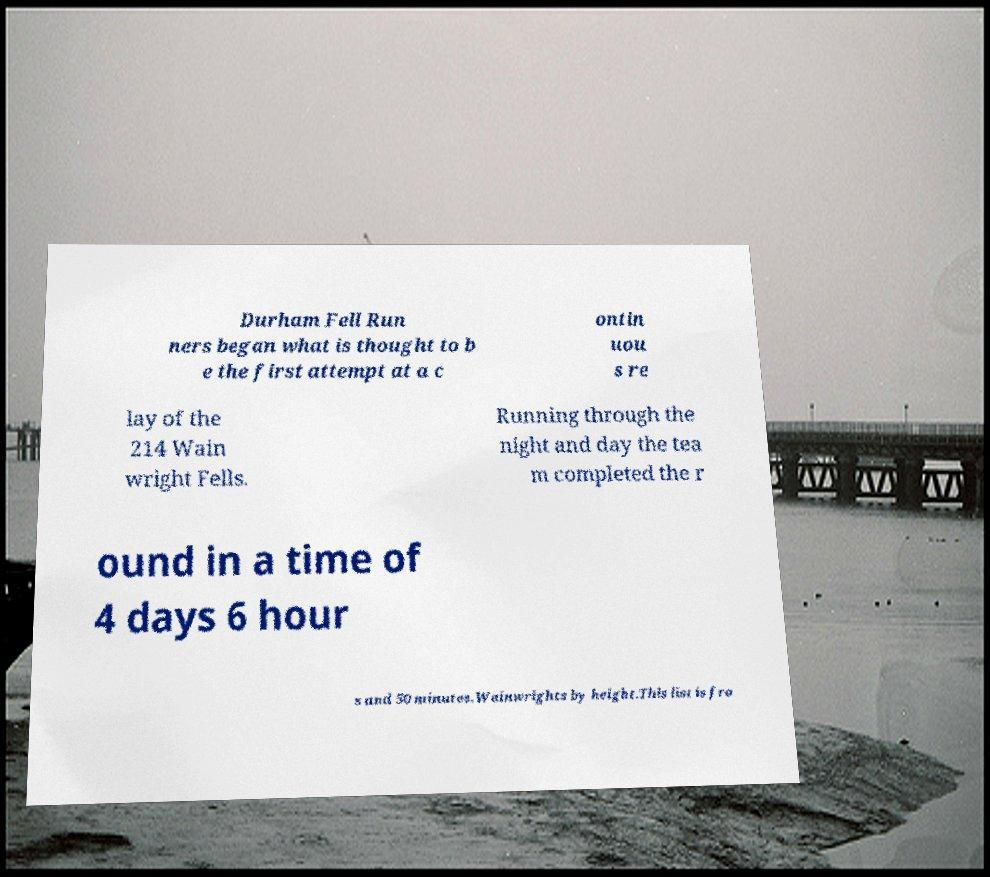What messages or text are displayed in this image? I need them in a readable, typed format. Durham Fell Run ners began what is thought to b e the first attempt at a c ontin uou s re lay of the 214 Wain wright Fells. Running through the night and day the tea m completed the r ound in a time of 4 days 6 hour s and 50 minutes.Wainwrights by height.This list is fro 